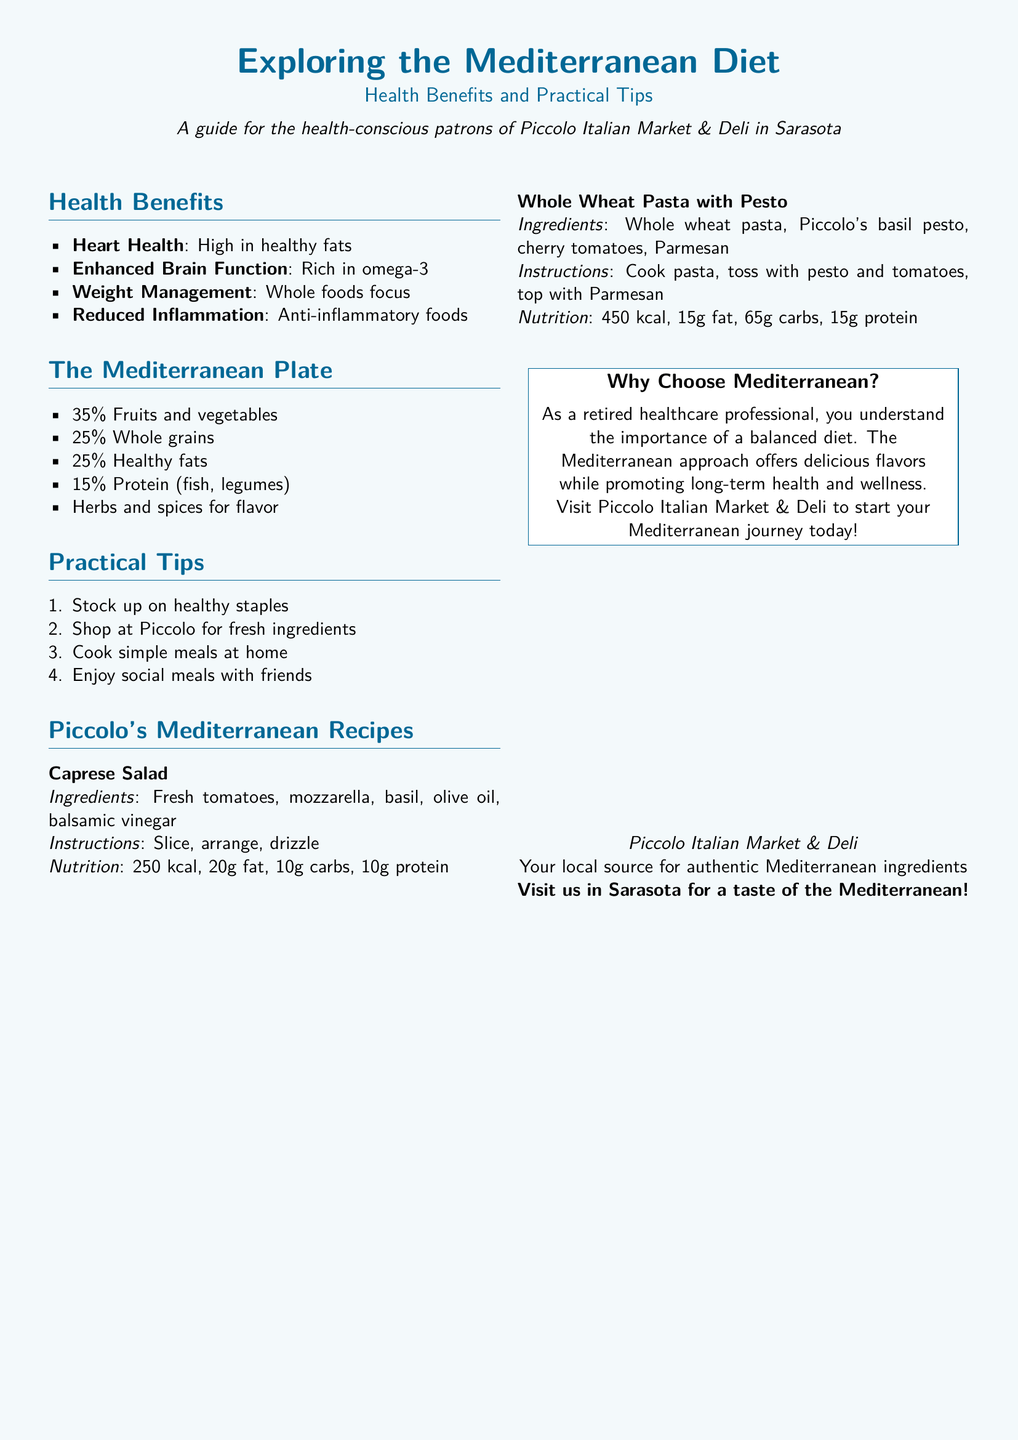What are the health benefits of the Mediterranean diet? The section outlines four key health benefits: heart health, enhanced brain function, weight management, and reduced inflammation.
Answer: Heart Health, Enhanced Brain Function, Weight Management, Reduced Inflammation What percentage of the Mediterranean plate is made up of fruits and vegetables? The document specifies that 35% of the Mediterranean plate consists of fruits and vegetables.
Answer: 35% Which recipe includes fresh tomatoes? The Caprese Salad recipe lists fresh tomatoes as an ingredient.
Answer: Caprese Salad How many grams of protein are in the Whole Wheat Pasta with Pesto dish? The nutritional information for the Whole Wheat Pasta with Pesto states it contains 15 grams of protein.
Answer: 15g What is the main protein source highlighted in the Mediterranean plate? The document mentions fish and legumes as the primary protein sources in the Mediterranean plate.
Answer: Fish, legumes What type of diet does the document promote? The document promotes the Mediterranean diet.
Answer: Mediterranean diet Where can patrons shop for healthy ingredients? The document encourages shopping at Piccolo Italian Market & Deli for fresh ingredients.
Answer: Piccolo Italian Market & Deli What is the calorie count for the Caprese Salad? The nutritional total for the Caprese Salad is listed as 250 kcal.
Answer: 250 kcal 